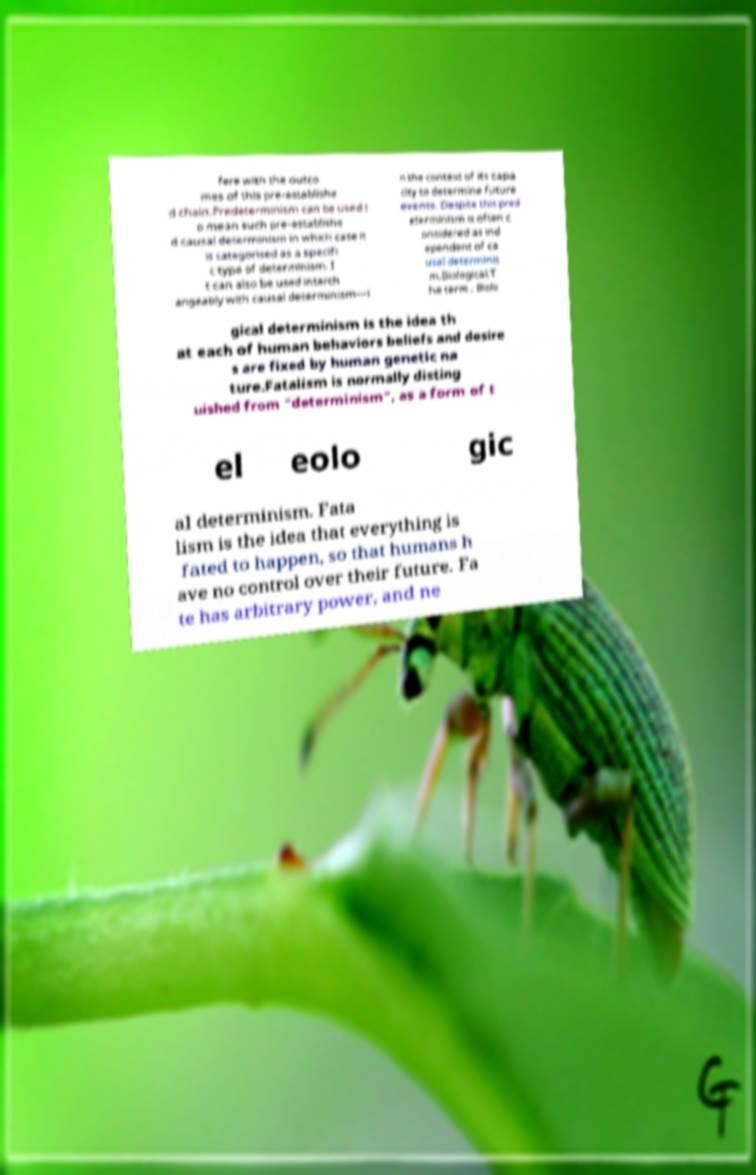Please read and relay the text visible in this image. What does it say? fere with the outco mes of this pre-establishe d chain.Predeterminism can be used t o mean such pre-establishe d causal determinism in which case it is categorised as a specifi c type of determinism. I t can also be used interch angeably with causal determinism—i n the context of its capa city to determine future events. Despite this pred eterminism is often c onsidered as ind ependent of ca usal determinis m.Biological.T he term . Biolo gical determinism is the idea th at each of human behaviors beliefs and desire s are fixed by human genetic na ture.Fatalism is normally disting uished from "determinism", as a form of t el eolo gic al determinism. Fata lism is the idea that everything is fated to happen, so that humans h ave no control over their future. Fa te has arbitrary power, and ne 